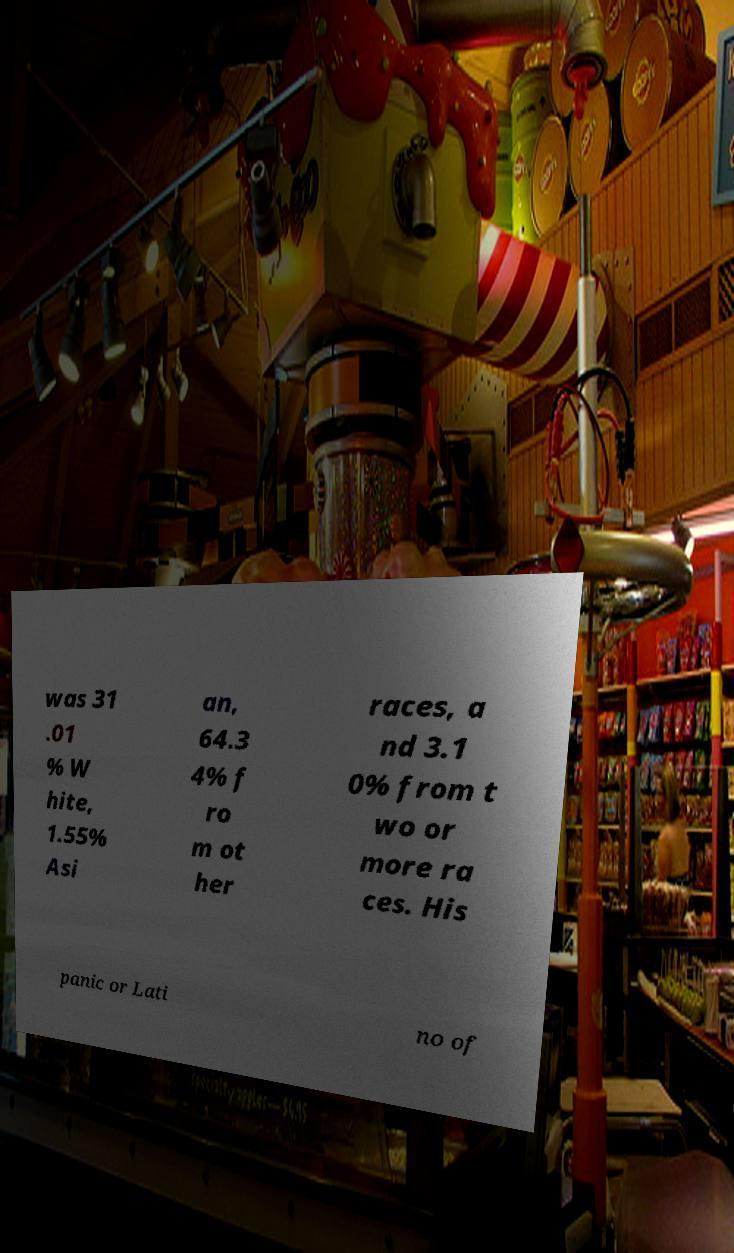Can you read and provide the text displayed in the image?This photo seems to have some interesting text. Can you extract and type it out for me? was 31 .01 % W hite, 1.55% Asi an, 64.3 4% f ro m ot her races, a nd 3.1 0% from t wo or more ra ces. His panic or Lati no of 